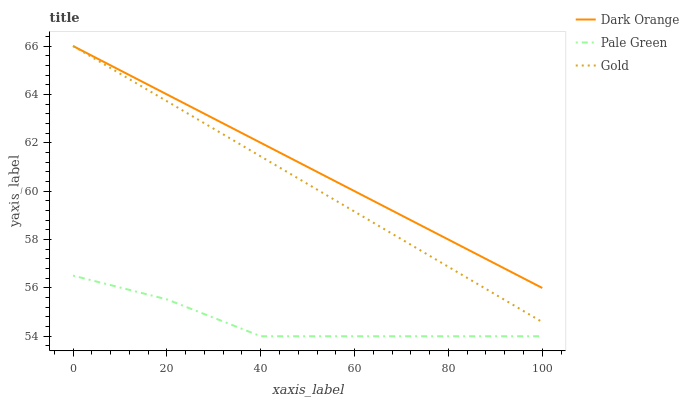Does Gold have the minimum area under the curve?
Answer yes or no. No. Does Gold have the maximum area under the curve?
Answer yes or no. No. Is Pale Green the smoothest?
Answer yes or no. No. Is Gold the roughest?
Answer yes or no. No. Does Gold have the lowest value?
Answer yes or no. No. Does Pale Green have the highest value?
Answer yes or no. No. Is Pale Green less than Dark Orange?
Answer yes or no. Yes. Is Dark Orange greater than Pale Green?
Answer yes or no. Yes. Does Pale Green intersect Dark Orange?
Answer yes or no. No. 